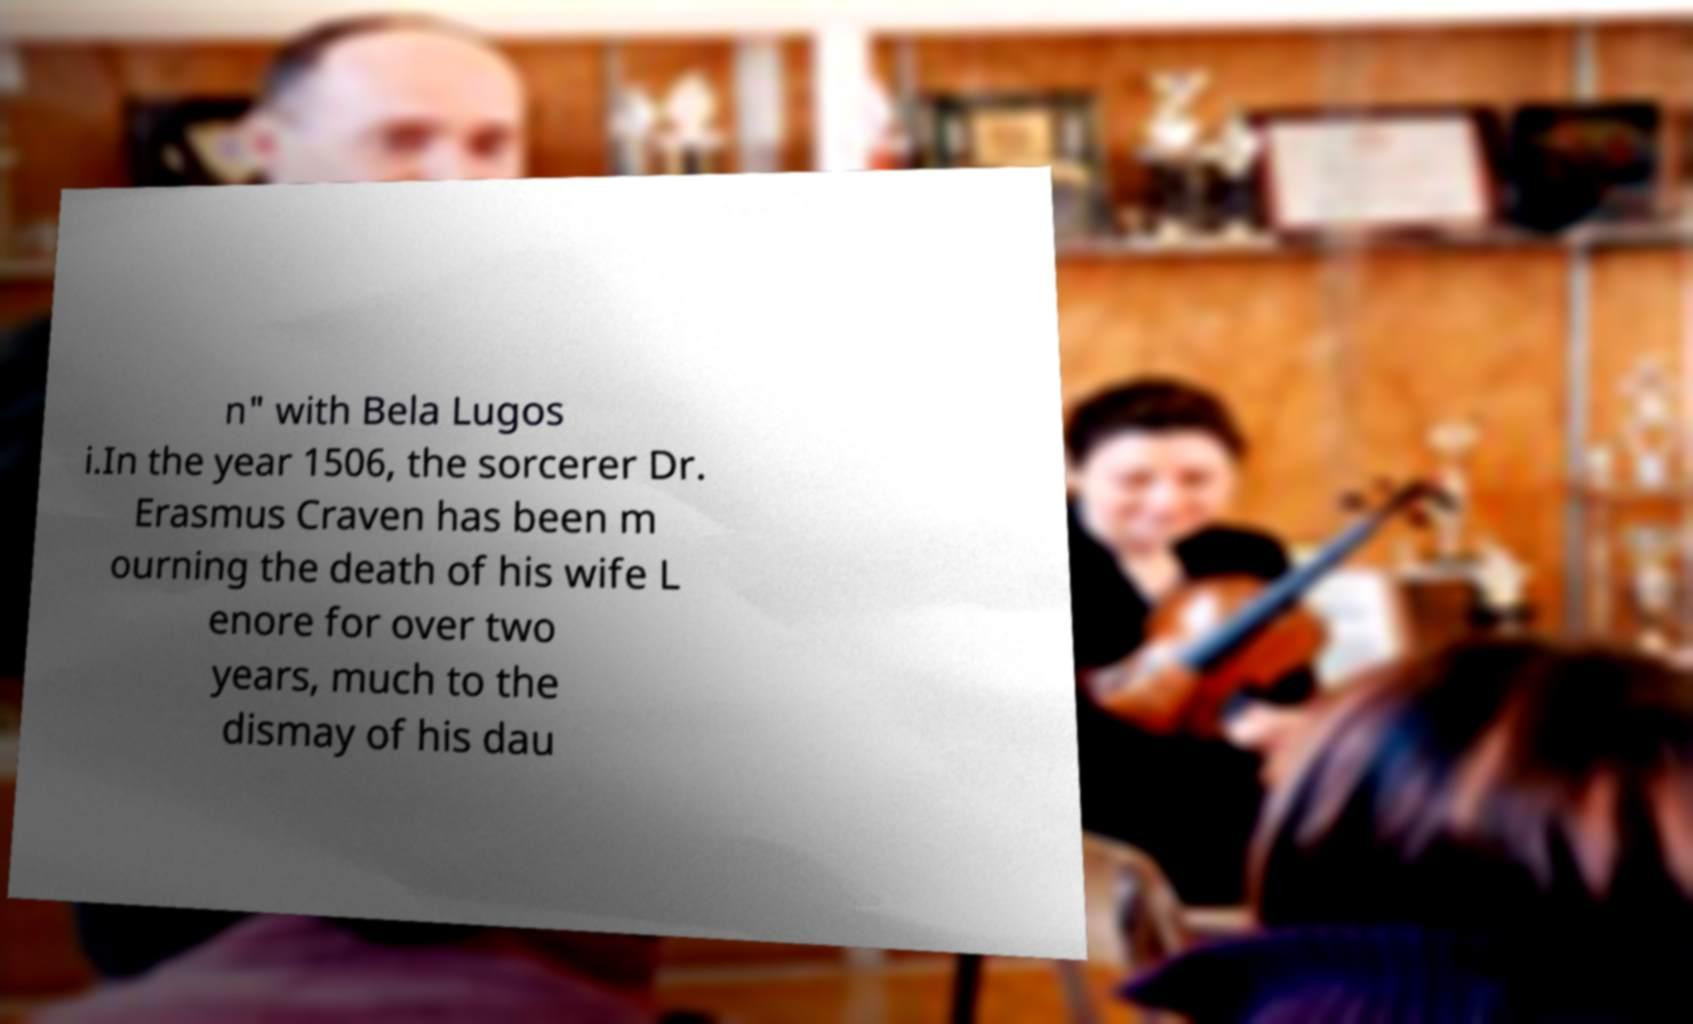I need the written content from this picture converted into text. Can you do that? n" with Bela Lugos i.In the year 1506, the sorcerer Dr. Erasmus Craven has been m ourning the death of his wife L enore for over two years, much to the dismay of his dau 